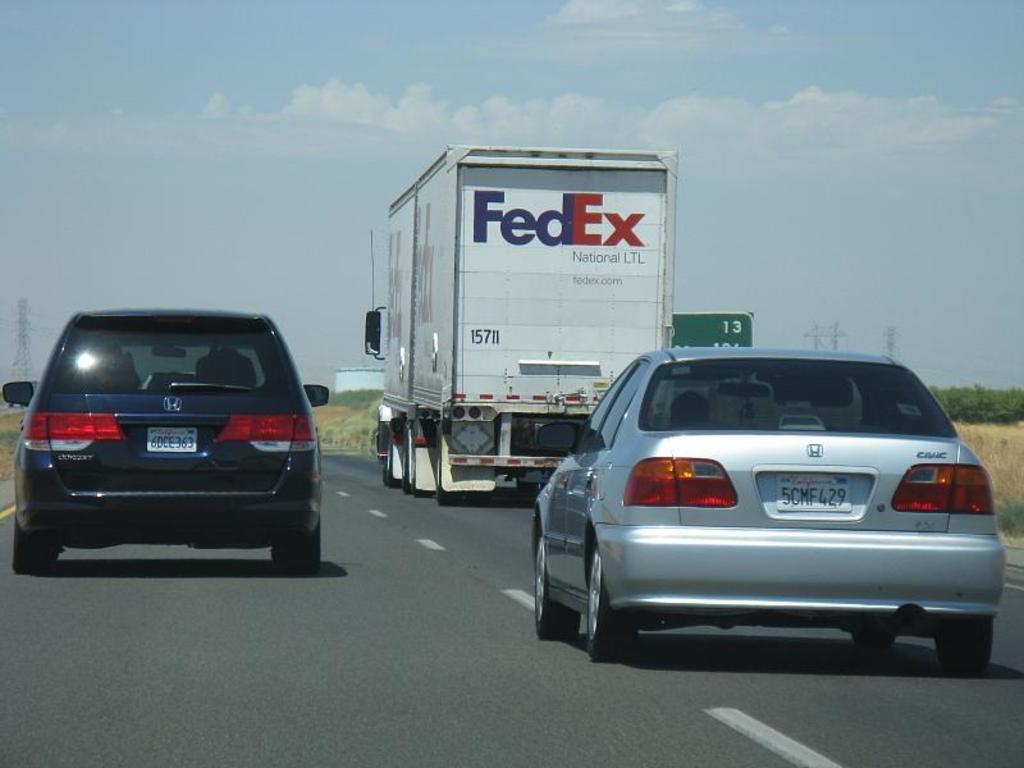What is happening on the road in the image? There are vehicles moving on the road in the image. What can be seen in the background of the image? There is a building, towers, a board with some text, and the sky visible in the background of the image. Where is the crib located in the image? There is no crib present in the image. What type of butter is present in the image? There is no butter present in the image. 